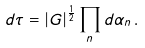Convert formula to latex. <formula><loc_0><loc_0><loc_500><loc_500>d \tau = | G | ^ { \frac { 1 } { 2 } } \prod _ { n } d \alpha _ { n } \, .</formula> 